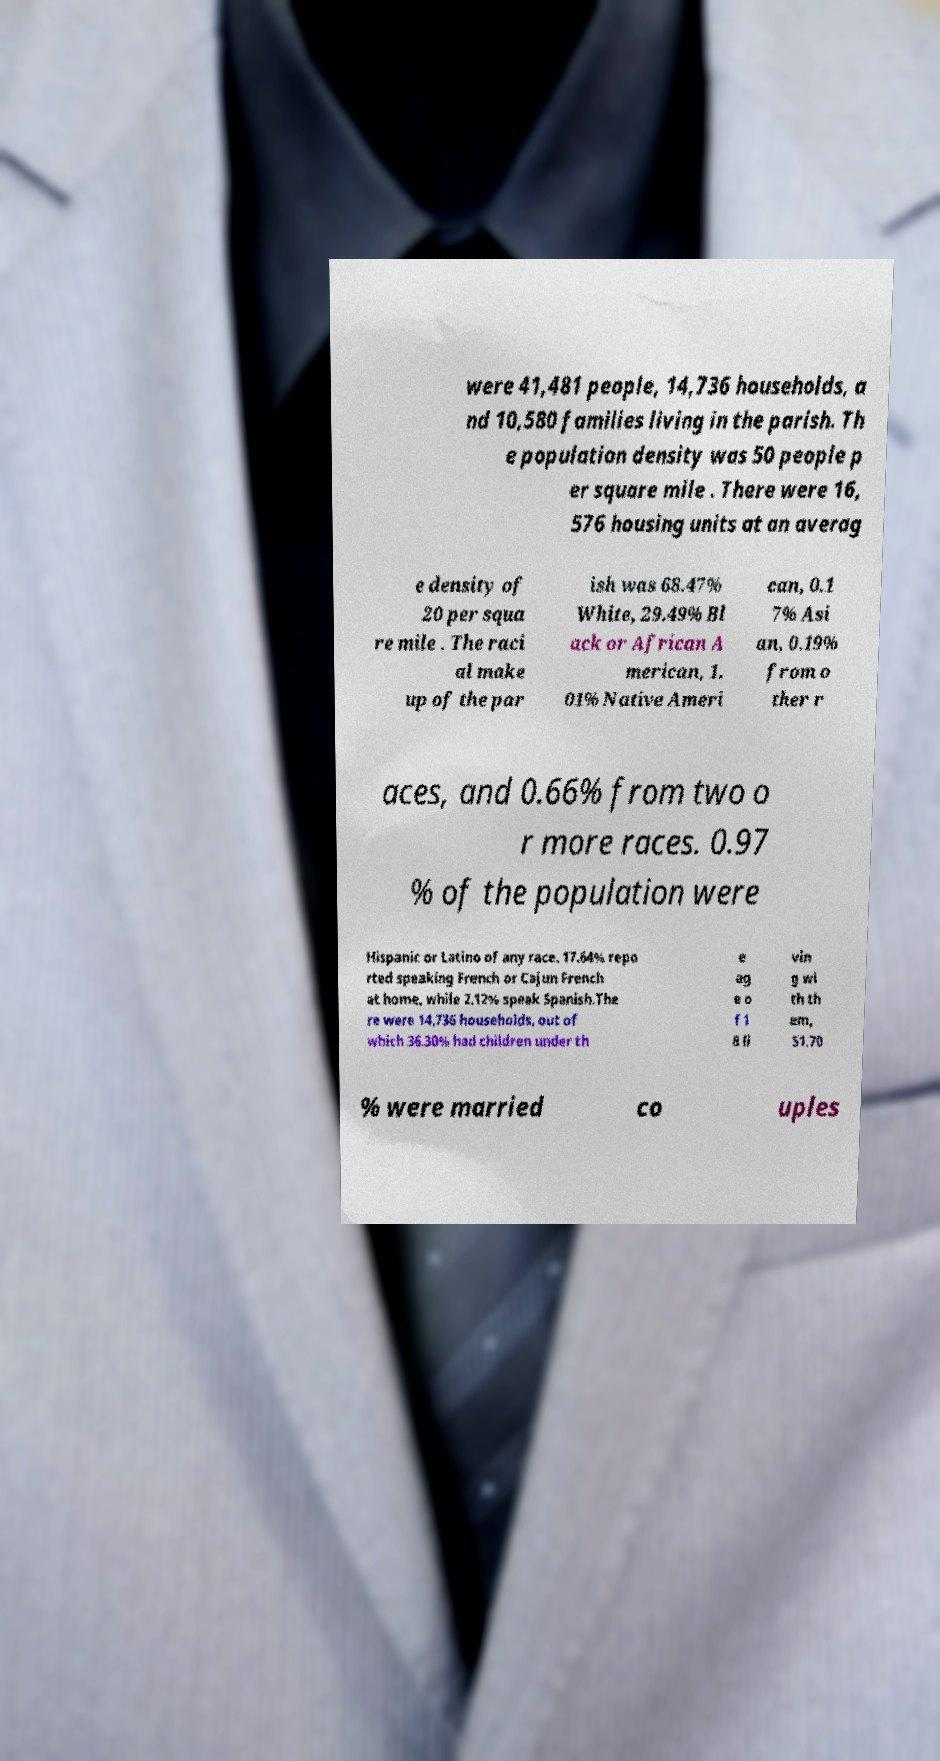Can you read and provide the text displayed in the image?This photo seems to have some interesting text. Can you extract and type it out for me? were 41,481 people, 14,736 households, a nd 10,580 families living in the parish. Th e population density was 50 people p er square mile . There were 16, 576 housing units at an averag e density of 20 per squa re mile . The raci al make up of the par ish was 68.47% White, 29.49% Bl ack or African A merican, 1. 01% Native Ameri can, 0.1 7% Asi an, 0.19% from o ther r aces, and 0.66% from two o r more races. 0.97 % of the population were Hispanic or Latino of any race. 17.64% repo rted speaking French or Cajun French at home, while 2.12% speak Spanish.The re were 14,736 households, out of which 36.30% had children under th e ag e o f 1 8 li vin g wi th th em, 51.70 % were married co uples 